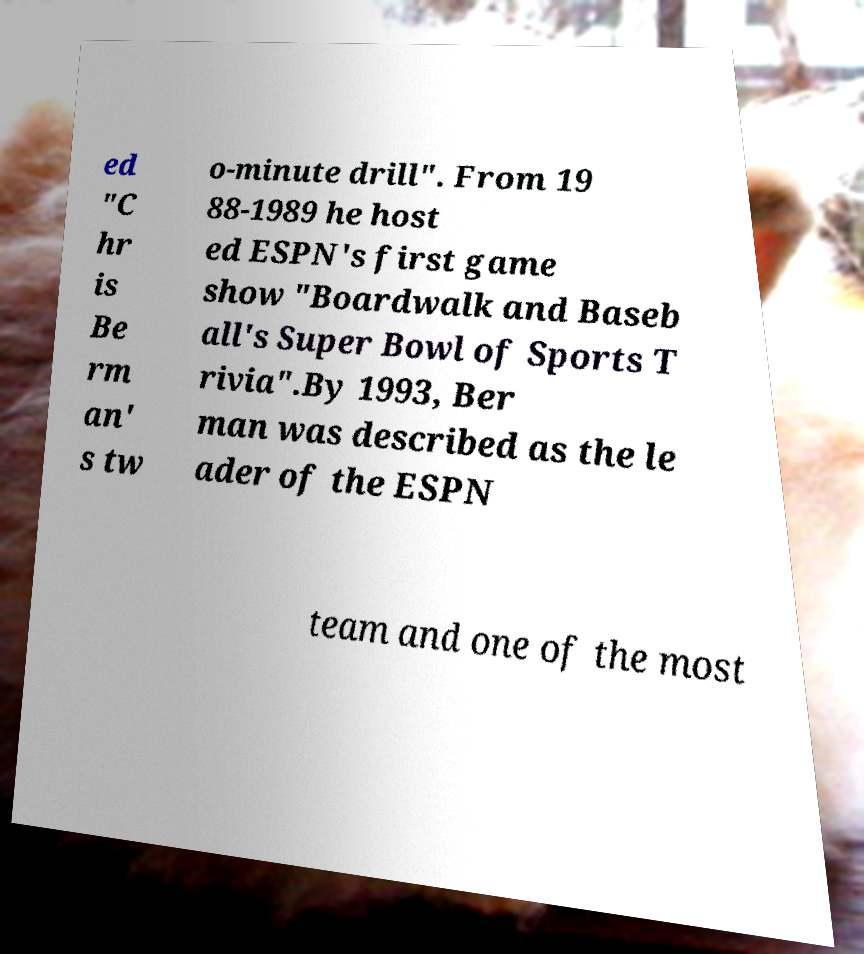I need the written content from this picture converted into text. Can you do that? ed "C hr is Be rm an' s tw o-minute drill". From 19 88-1989 he host ed ESPN's first game show "Boardwalk and Baseb all's Super Bowl of Sports T rivia".By 1993, Ber man was described as the le ader of the ESPN team and one of the most 